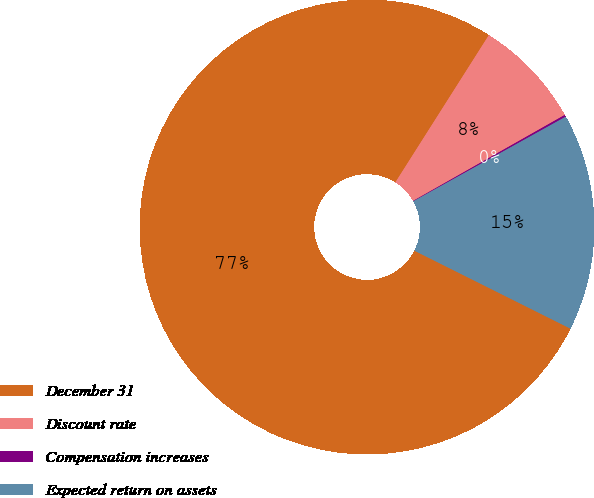Convert chart. <chart><loc_0><loc_0><loc_500><loc_500><pie_chart><fcel>December 31<fcel>Discount rate<fcel>Compensation increases<fcel>Expected return on assets<nl><fcel>76.63%<fcel>7.79%<fcel>0.14%<fcel>15.44%<nl></chart> 